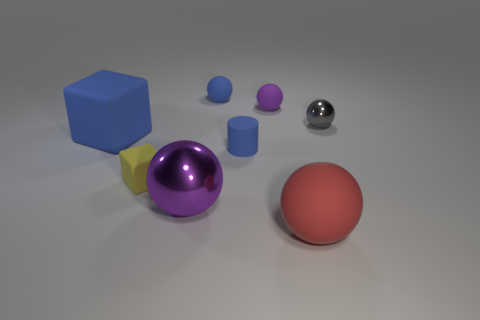Can you describe the arrangement of shapes from left to right? Sure, from left to right, there is a blue cube, a yellow four-sided figure that's somewhat obscured, a large purple sphere, two smaller purple spheres, a small metal sphere, and a large red matte sphere. 